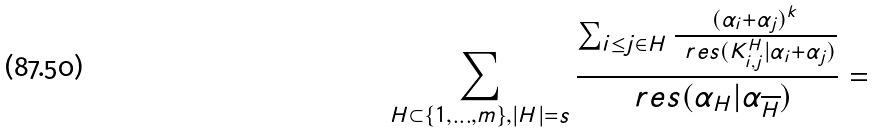<formula> <loc_0><loc_0><loc_500><loc_500>\sum _ { H \subset \{ 1 , \dots , m \} , | H | = s } \frac { \sum _ { i \leq j \in H } \frac { ( \alpha _ { i } + \alpha _ { j } ) ^ { k } } { \ r e s ( K ^ { H } _ { i , j } | \alpha _ { i } + \alpha _ { j } ) } } { \ r e s ( \alpha _ { H } | \alpha _ { \overline { H } } ) } =</formula> 